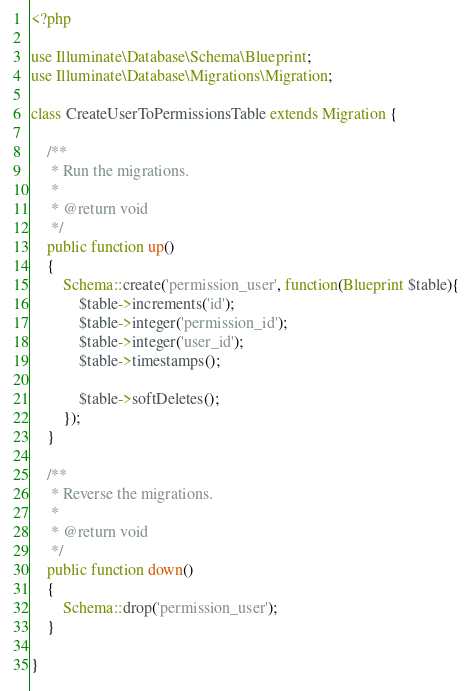<code> <loc_0><loc_0><loc_500><loc_500><_PHP_><?php

use Illuminate\Database\Schema\Blueprint;
use Illuminate\Database\Migrations\Migration;

class CreateUserToPermissionsTable extends Migration {

	/**
	 * Run the migrations.
	 *
	 * @return void
	 */
	public function up()
	{
        Schema::create('permission_user', function(Blueprint $table){
            $table->increments('id');
            $table->integer('permission_id');
            $table->integer('user_id');
            $table->timestamps();

            $table->softDeletes();
        });
	}

	/**
	 * Reverse the migrations.
	 *
	 * @return void
	 */
	public function down()
	{
        Schema::drop('permission_user');
	}

}
</code> 